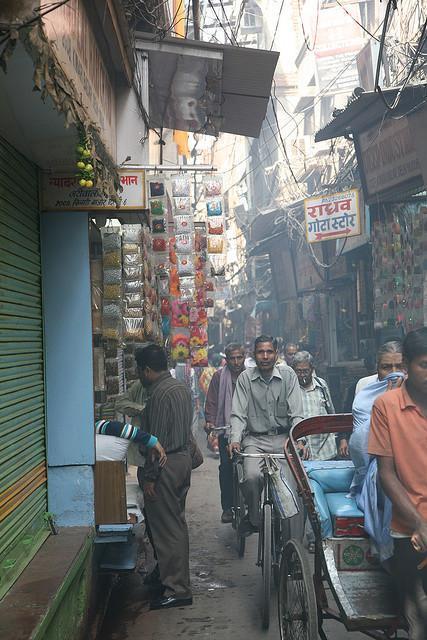How many bike riders are there?
Give a very brief answer. 2. How many people are there?
Give a very brief answer. 6. 